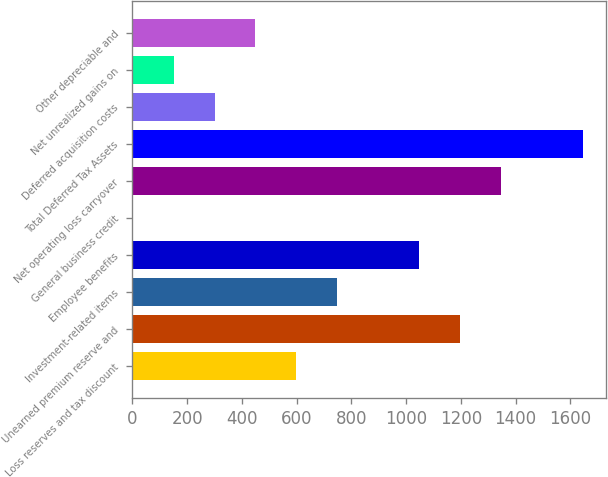<chart> <loc_0><loc_0><loc_500><loc_500><bar_chart><fcel>Loss reserves and tax discount<fcel>Unearned premium reserve and<fcel>Investment-related items<fcel>Employee benefits<fcel>General business credit<fcel>Net operating loss carryover<fcel>Total Deferred Tax Assets<fcel>Deferred acquisition costs<fcel>Net unrealized gains on<fcel>Other depreciable and<nl><fcel>599.4<fcel>1197.8<fcel>749<fcel>1048.2<fcel>1<fcel>1347.4<fcel>1646.6<fcel>300.2<fcel>150.6<fcel>449.8<nl></chart> 